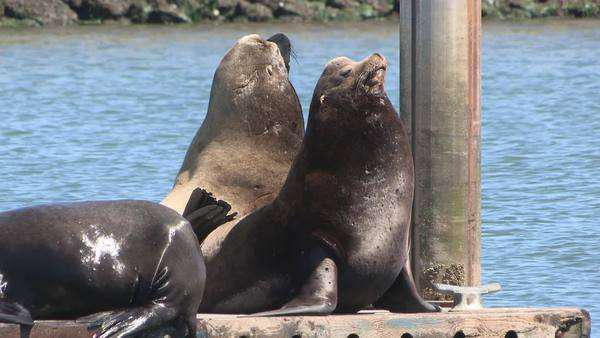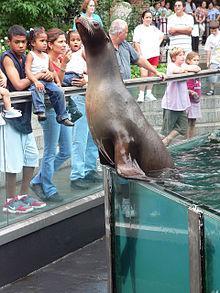The first image is the image on the left, the second image is the image on the right. Given the left and right images, does the statement "There is a seal with a fish hanging from the left side of their mouth" hold true? Answer yes or no. No. The first image is the image on the left, the second image is the image on the right. For the images displayed, is the sentence "The seal in the right image has a fish in it's mouth." factually correct? Answer yes or no. No. 